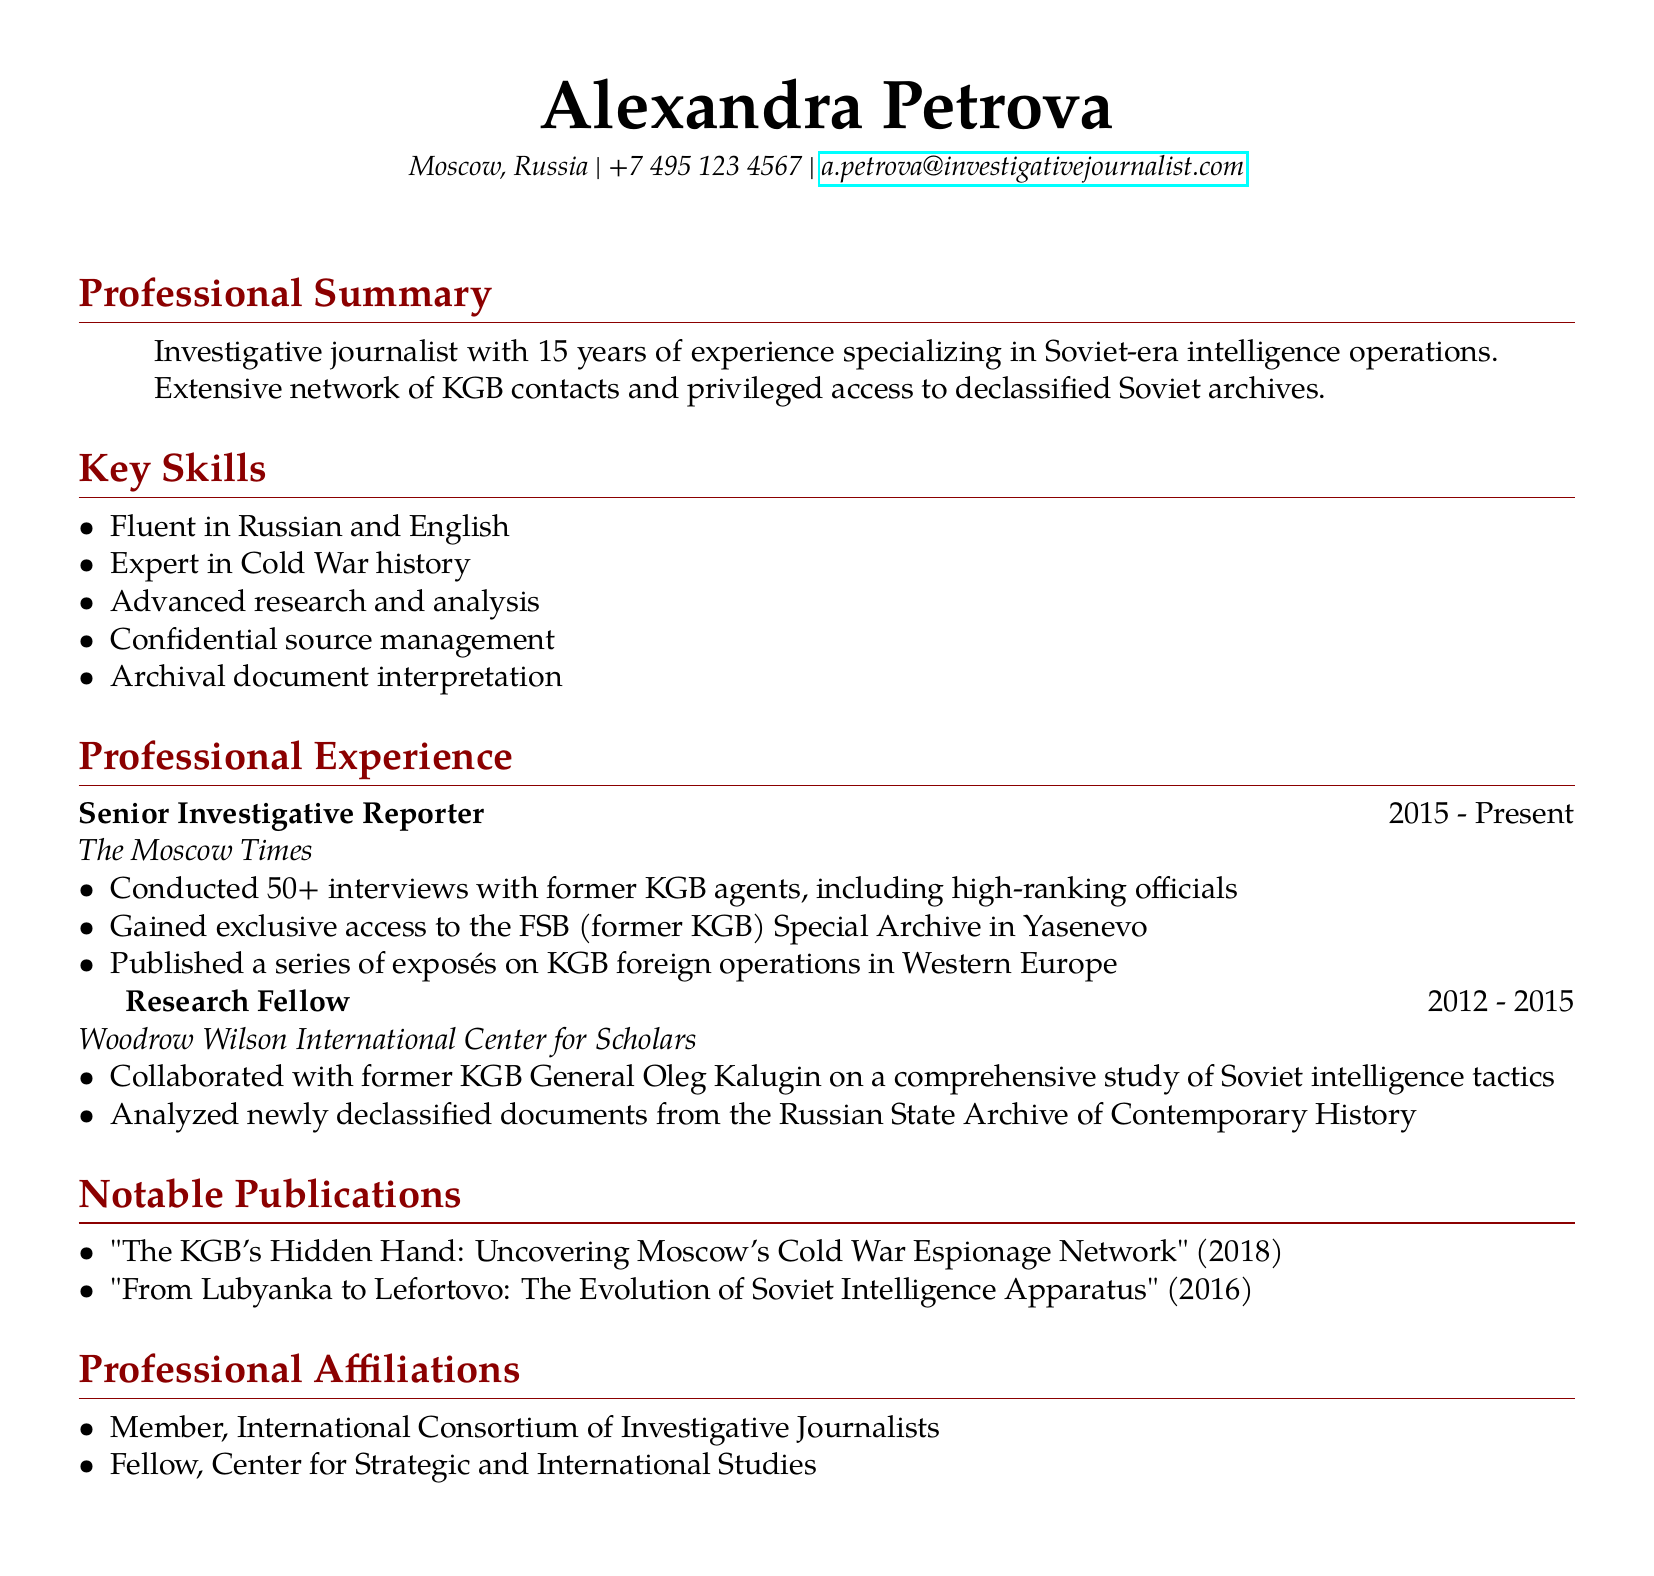What is the name of the journalist? The name of the journalist is presented at the beginning of the document.
Answer: Alexandra Petrova What is Alexandra Petrova's primary area of expertise? The document states that she specializes in Soviet-era intelligence operations.
Answer: Soviet-era intelligence operations How many years of experience does she have? The professional summary indicates her total years of experience in the field.
Answer: 15 years What organization did Alexandra work for as a Senior Investigative Reporter? The document specifies the organization where she held the senior position in her professional experience.
Answer: The Moscow Times Who did she collaborate with at the Woodrow Wilson International Center for Scholars? The document mentions a specific individual with whom she worked during her time as a research fellow.
Answer: Oleg Kalugin How many interviews did she conduct with former KGB agents? The achievements section under her current role states the number of interviews she completed.
Answer: 50+ What notable publication was released in 2018? The notable publications section of the document lists her work along with their release years.
Answer: "The KGB's Hidden Hand: Uncovering Moscow's Cold War Espionage Network" What is one key skill listed in her resume? The key skills section provides a list of specific skills she possesses.
Answer: Fluent in Russian and English What is the purpose of her access to declassified archives? The document highlights her ability to access restricted materials related to her field of work.
Answer: Research on Soviet-era intelligence 